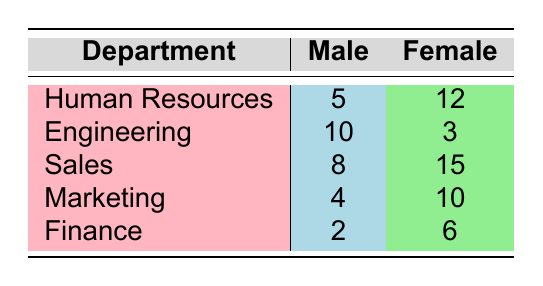What is the total number of harassment incidents reported in the Sales department? The Sales department has 8 incidents reported by males and 15 incidents reported by females. To find the total, we add these two numbers: 8 + 15 = 23.
Answer: 23 How many more harassment incidents were reported by females than by males in the Human Resources department? In the Human Resources department, there are 12 incidents reported by females and 5 by males. To find the difference, we subtract the number of male incidents from the female incidents: 12 - 5 = 7.
Answer: 7 Is it true that the Engineering department has more reported harassment incidents involving males than females? The Engineering department has 10 incidents involving males and 3 involving females. Since 10 is greater than 3, the statement is true.
Answer: Yes What is the average number of harassment incidents reported by females across all departments? To find the average, we sum the number of incidents reported by females in each department: 12 (HR) + 3 (Eng) + 15 (Sales) + 10 (Mktg) + 6 (Fin) = 46. There are 5 departments, so we calculate the average: 46 / 5 = 9.2.
Answer: 9.2 Which department has the highest number of harassment incidents reported by females, and how many incidents were reported? By comparing the number of female incidents across departments: HR (12), Eng (3), Sales (15), Mktg (10), Fin (6), we see the highest is in the Sales department with 15 incidents.
Answer: Sales, 15 What is the total number of harassment incidents reported by males across all departments? We add the number of male incidents reported in each department: 5 (HR) + 10 (Eng) + 8 (Sales) + 4 (Mktg) + 2 (Fin) = 29.
Answer: 29 Is the total number of reported harassment incidents higher for males in the Engineering department than for females in the Marketing department? The Engineering department has 10 incidents reported by males, while the Marketing department has 10 incidents reported by females. Since 10 is equal to 10, the statement is false.
Answer: No What department has the least number of harassment incidents reported by both genders combined? We first find the total for each department: HR (5+12=17), Eng (10+3=13), Sales (8+15=23), Mktg (4+10=14), Fin (2+6=8). The Finance department has the lowest total of 8 incidents.
Answer: Finance, 8 How many more harassment incidents were reported by females in the Sales department compared to the Finance department? In the Sales department, there are 15 incidents reported by females, and in the Finance department, there are 6. The difference is calculated by subtracting: 15 - 6 = 9.
Answer: 9 